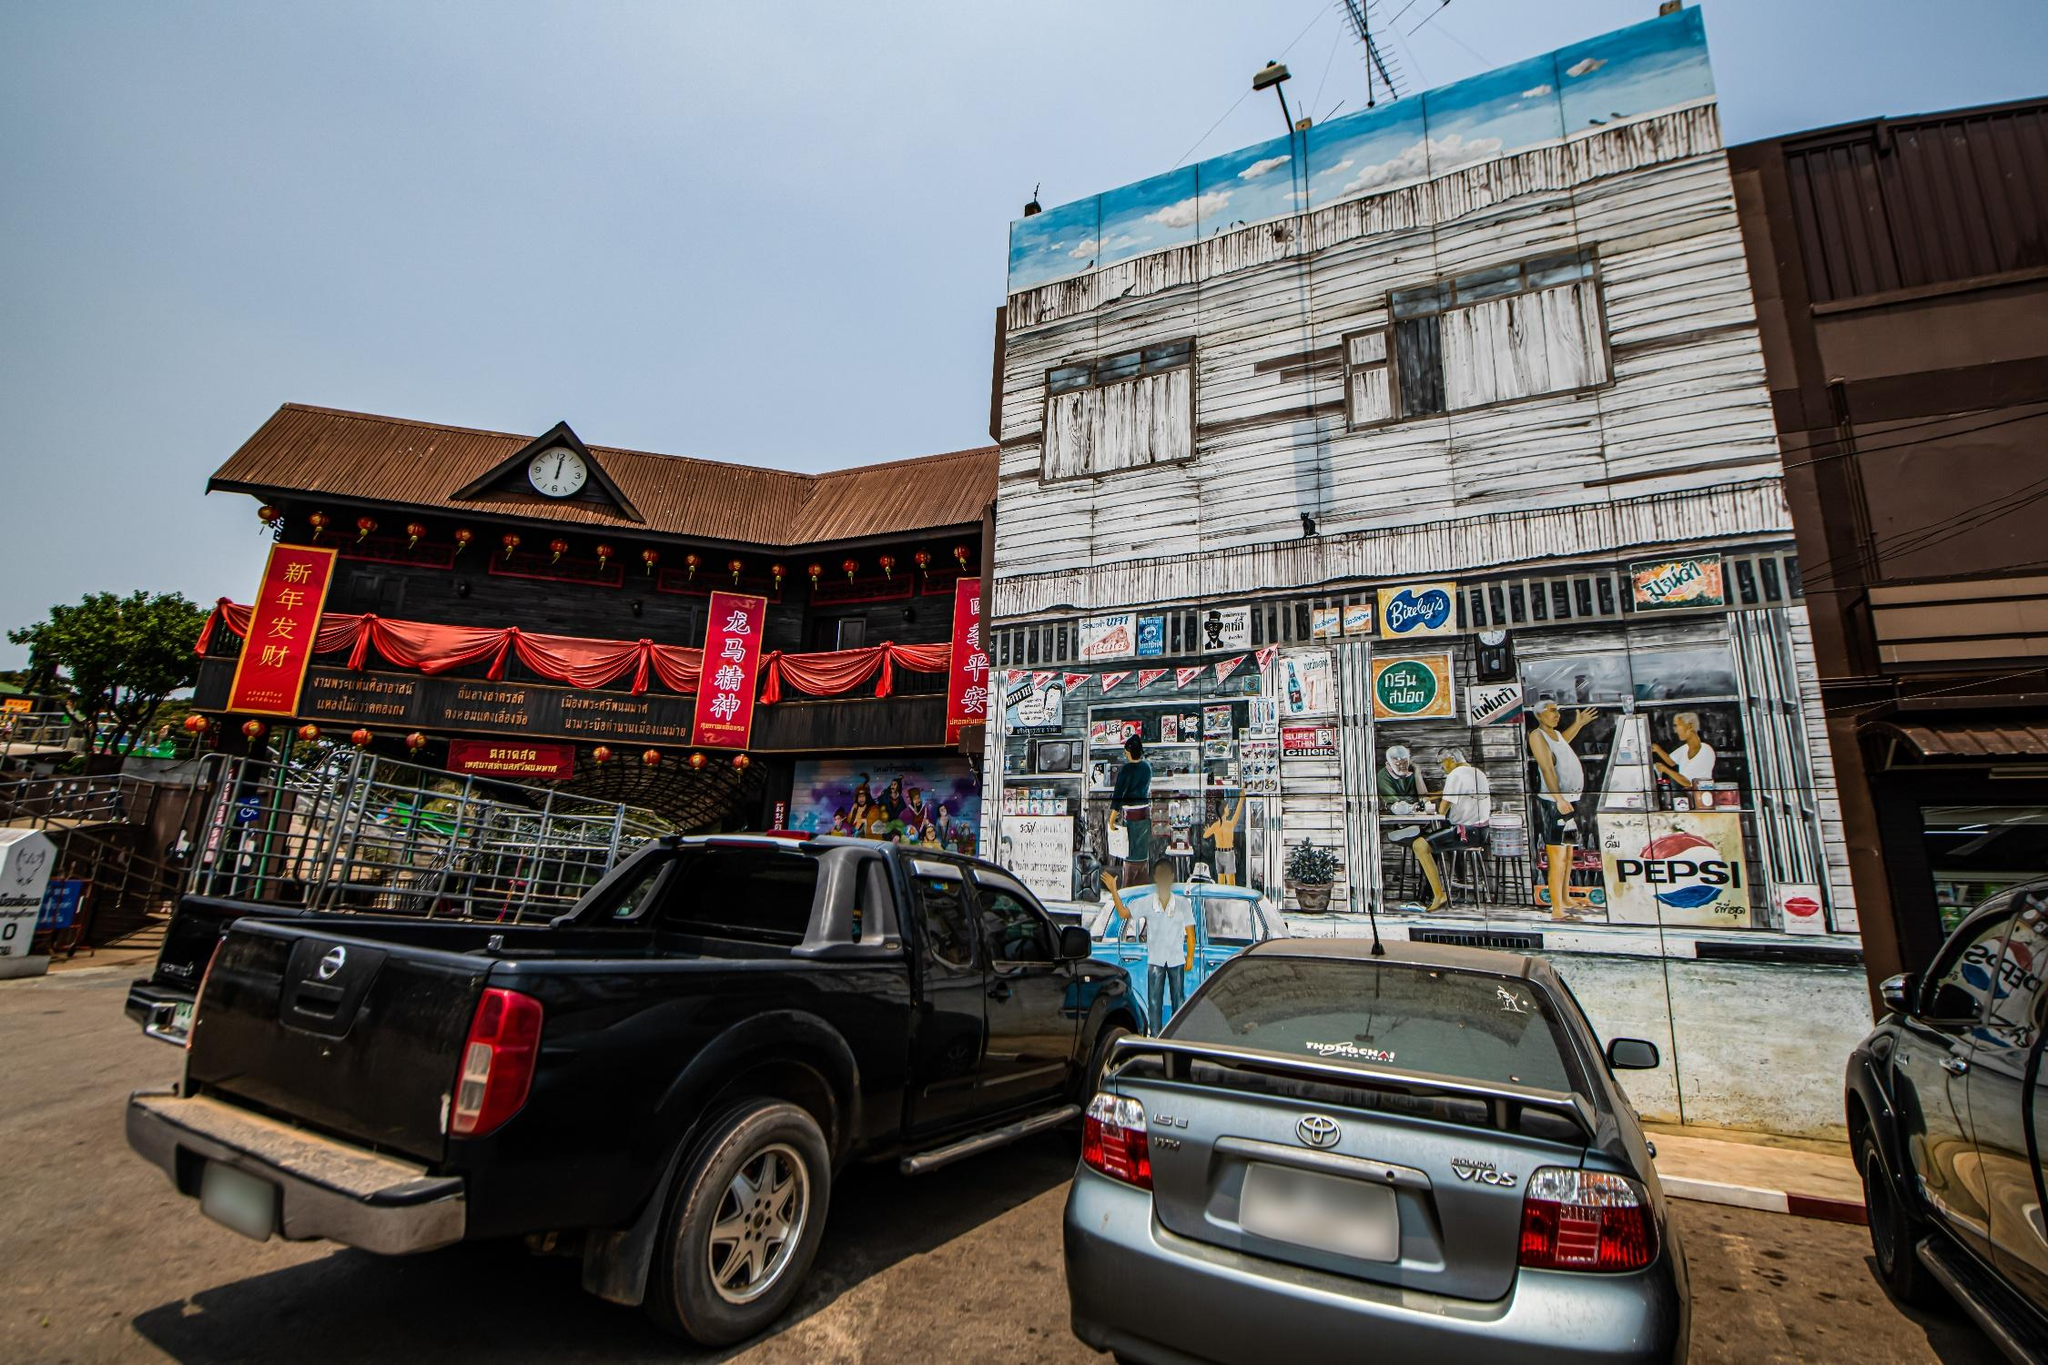What can you tell me about the cultural influences visible in the architecture and decorations? The architecture and decorations in the image reflect a rich tapestry of cultural influences. On the left, the building adorned with red banners and traditional Chinese characters suggests influences from Chinese culture, likely tied to a community celebration or festival. Contrasting this, the building on the right shows wear but is brought to life with vibrant commercial murals, indicating a blend of local practices and global commercial branding. Such visuals speak to the community's multicultural make-up and its adaptation to both local traditions and global influences. 